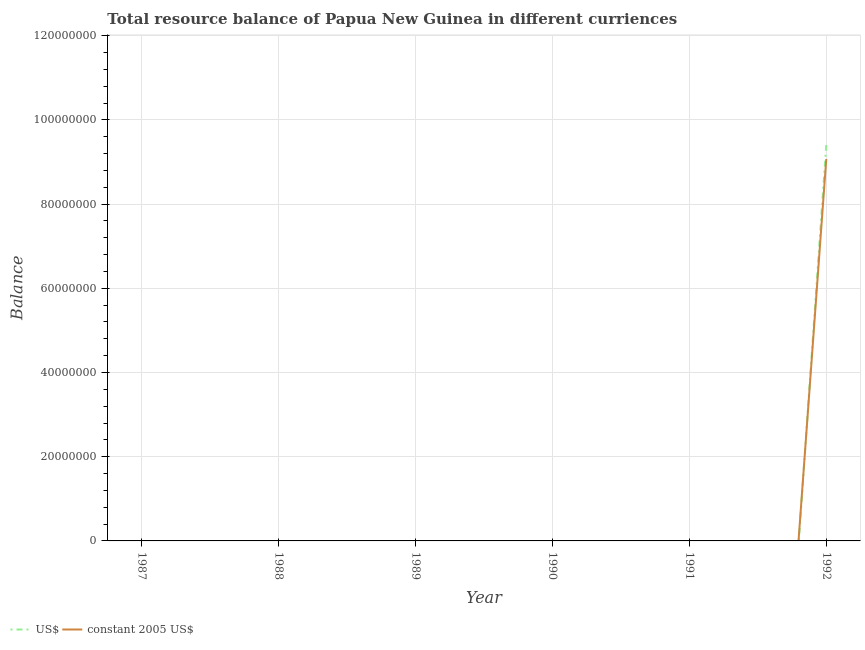What is the resource balance in constant us$ in 1991?
Keep it short and to the point. 0. Across all years, what is the maximum resource balance in constant us$?
Your answer should be very brief. 9.07e+07. In which year was the resource balance in constant us$ maximum?
Your answer should be very brief. 1992. What is the total resource balance in us$ in the graph?
Offer a very short reply. 9.40e+07. What is the average resource balance in constant us$ per year?
Ensure brevity in your answer.  1.51e+07. In the year 1992, what is the difference between the resource balance in us$ and resource balance in constant us$?
Offer a terse response. 3.33e+06. What is the difference between the highest and the lowest resource balance in constant us$?
Provide a succinct answer. 9.07e+07. Is the resource balance in constant us$ strictly greater than the resource balance in us$ over the years?
Your answer should be very brief. No. How many lines are there?
Offer a very short reply. 2. What is the difference between two consecutive major ticks on the Y-axis?
Ensure brevity in your answer.  2.00e+07. Are the values on the major ticks of Y-axis written in scientific E-notation?
Your response must be concise. No. Does the graph contain grids?
Your answer should be compact. Yes. What is the title of the graph?
Make the answer very short. Total resource balance of Papua New Guinea in different curriences. What is the label or title of the X-axis?
Your answer should be compact. Year. What is the label or title of the Y-axis?
Offer a terse response. Balance. What is the Balance in constant 2005 US$ in 1987?
Your response must be concise. 0. What is the Balance of US$ in 1988?
Offer a terse response. 0. What is the Balance in US$ in 1989?
Provide a succinct answer. 0. What is the Balance of constant 2005 US$ in 1990?
Provide a short and direct response. 0. What is the Balance of US$ in 1992?
Offer a very short reply. 9.40e+07. What is the Balance of constant 2005 US$ in 1992?
Your response must be concise. 9.07e+07. Across all years, what is the maximum Balance of US$?
Your answer should be very brief. 9.40e+07. Across all years, what is the maximum Balance in constant 2005 US$?
Your response must be concise. 9.07e+07. What is the total Balance in US$ in the graph?
Ensure brevity in your answer.  9.40e+07. What is the total Balance in constant 2005 US$ in the graph?
Make the answer very short. 9.07e+07. What is the average Balance of US$ per year?
Provide a succinct answer. 1.57e+07. What is the average Balance in constant 2005 US$ per year?
Your answer should be very brief. 1.51e+07. In the year 1992, what is the difference between the Balance of US$ and Balance of constant 2005 US$?
Your answer should be compact. 3.33e+06. What is the difference between the highest and the lowest Balance of US$?
Keep it short and to the point. 9.40e+07. What is the difference between the highest and the lowest Balance in constant 2005 US$?
Give a very brief answer. 9.07e+07. 